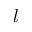<formula> <loc_0><loc_0><loc_500><loc_500>l</formula> 